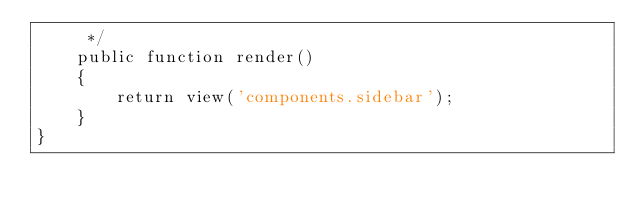Convert code to text. <code><loc_0><loc_0><loc_500><loc_500><_PHP_>     */
    public function render()
    {
        return view('components.sidebar');
    }
}
</code> 